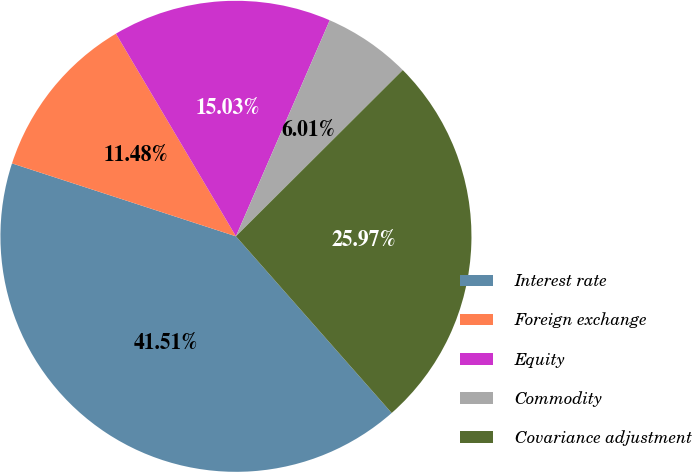<chart> <loc_0><loc_0><loc_500><loc_500><pie_chart><fcel>Interest rate<fcel>Foreign exchange<fcel>Equity<fcel>Commodity<fcel>Covariance adjustment<nl><fcel>41.51%<fcel>11.48%<fcel>15.03%<fcel>6.01%<fcel>25.97%<nl></chart> 